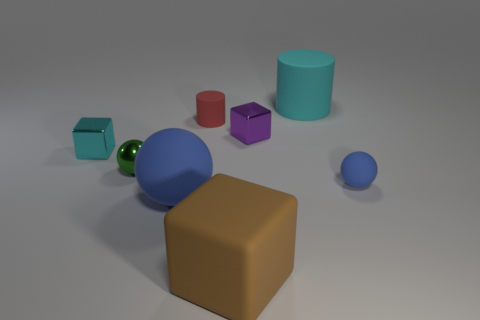There is a big thing that is behind the tiny cylinder; is its color the same as the block left of the brown rubber object?
Provide a succinct answer. Yes. How many other things are the same shape as the brown matte object?
Your answer should be very brief. 2. Are there any big purple blocks?
Your answer should be very brief. No. How many things are either tiny objects or rubber spheres in front of the small blue ball?
Provide a succinct answer. 6. Is the size of the matte cylinder behind the red matte object the same as the big rubber cube?
Your response must be concise. Yes. How many other objects are the same size as the cyan rubber object?
Keep it short and to the point. 2. What color is the rubber block?
Your answer should be compact. Brown. There is a thing behind the red rubber object; what is it made of?
Provide a short and direct response. Rubber. Is the number of blue balls that are right of the big cyan cylinder the same as the number of tiny cylinders?
Offer a terse response. Yes. Does the tiny red object have the same shape as the cyan metal object?
Ensure brevity in your answer.  No. 